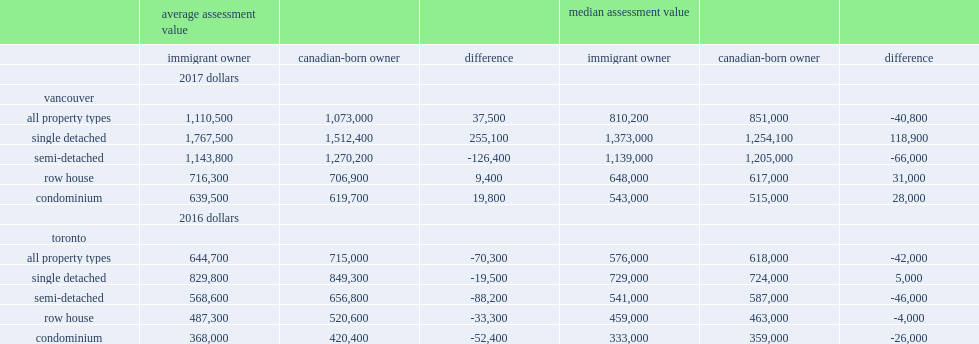How much is single-detached houses owned by immigrants average in vancouver? 1767500.0. How much more is the value of single-detached houses owned by immigrants average than the average value of single-detached homes owned by the canadian-born in vancouver? 0.168672. Whose semi-detached houses have lower average assessment values in vancouver, immigrant or canadian-born residents? Immigrant owner. Which one has a smaller difference in average valuation in vancouver, condominiums or semi-detached houses? Condominium. Which one has a smaller difference in average valuation in vancouver, row houses or semi-detached houses? Row house. How much is the average value of immigrant-owned dwellings lower than those owned by canadian-born residents in toronto for semi-detached houses? 88200. What kind of houses in toronto has the largest difference in average value? Semi-detached. How much is the average assessment value for immigrant-owned condominium apartments lower than those owned by canadian-born residents in toronto for semi-detached houses? 52400. Which one has a smaller differences in average assessment value in toronto, single-detached houses or condominium apartments? Single detached. 